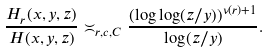<formula> <loc_0><loc_0><loc_500><loc_500>\frac { H _ { r } ( x , y , z ) } { H ( x , y , z ) } \asymp _ { r , c , C } \frac { ( \log \log ( z / y ) ) ^ { \nu ( r ) + 1 } } { \log ( z / y ) } .</formula> 